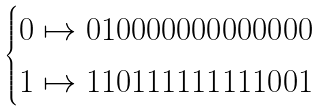<formula> <loc_0><loc_0><loc_500><loc_500>\begin{cases} 0 \mapsto 0 1 0 0 0 0 0 0 0 0 0 0 0 0 0 \\ 1 \mapsto 1 1 0 1 1 1 1 1 1 1 1 1 0 0 1 \end{cases}</formula> 